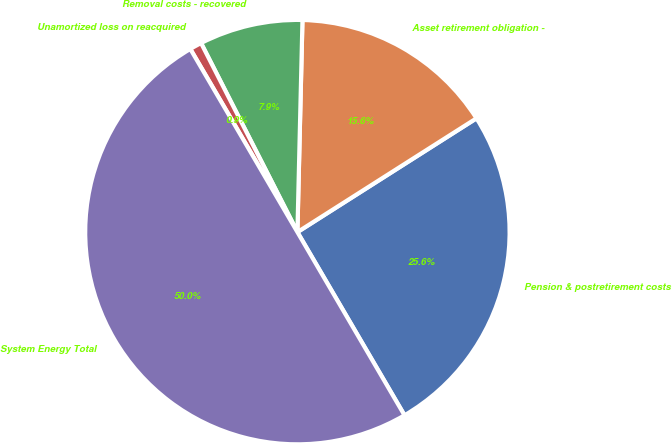<chart> <loc_0><loc_0><loc_500><loc_500><pie_chart><fcel>Pension & postretirement costs<fcel>Asset retirement obligation -<fcel>Removal costs - recovered<fcel>Unamortized loss on reacquired<fcel>System Energy Total<nl><fcel>25.59%<fcel>15.61%<fcel>7.88%<fcel>0.92%<fcel>50.0%<nl></chart> 